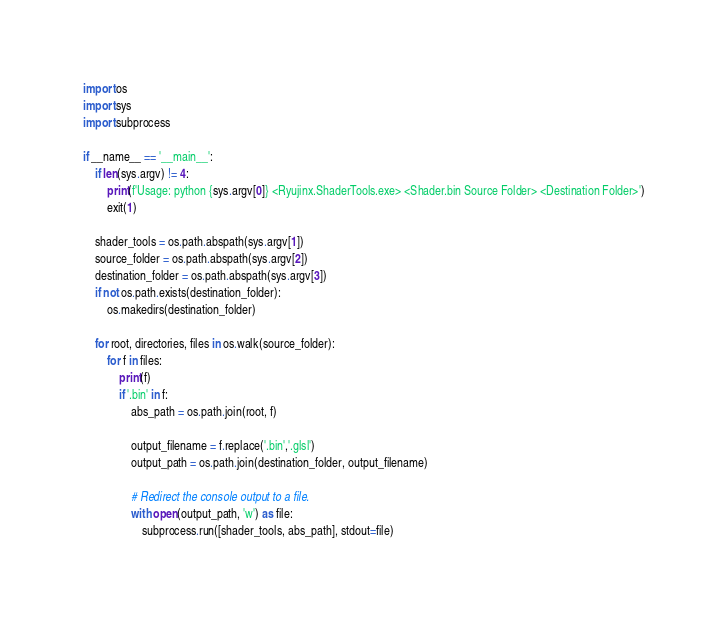Convert code to text. <code><loc_0><loc_0><loc_500><loc_500><_Python_>import os
import sys
import subprocess

if __name__ == '__main__':
    if len(sys.argv) != 4:
        print(f'Usage: python {sys.argv[0]} <Ryujinx.ShaderTools.exe> <Shader.bin Source Folder> <Destination Folder>')
        exit(1)

    shader_tools = os.path.abspath(sys.argv[1])
    source_folder = os.path.abspath(sys.argv[2])
    destination_folder = os.path.abspath(sys.argv[3])
    if not os.path.exists(destination_folder):
        os.makedirs(destination_folder)

    for root, directories, files in os.walk(source_folder):
        for f in files:
            print(f)
            if '.bin' in f:
                abs_path = os.path.join(root, f)

                output_filename = f.replace('.bin','.glsl')
                output_path = os.path.join(destination_folder, output_filename)
               
                # Redirect the console output to a file.
                with open(output_path, 'w') as file:
                    subprocess.run([shader_tools, abs_path], stdout=file)
</code> 